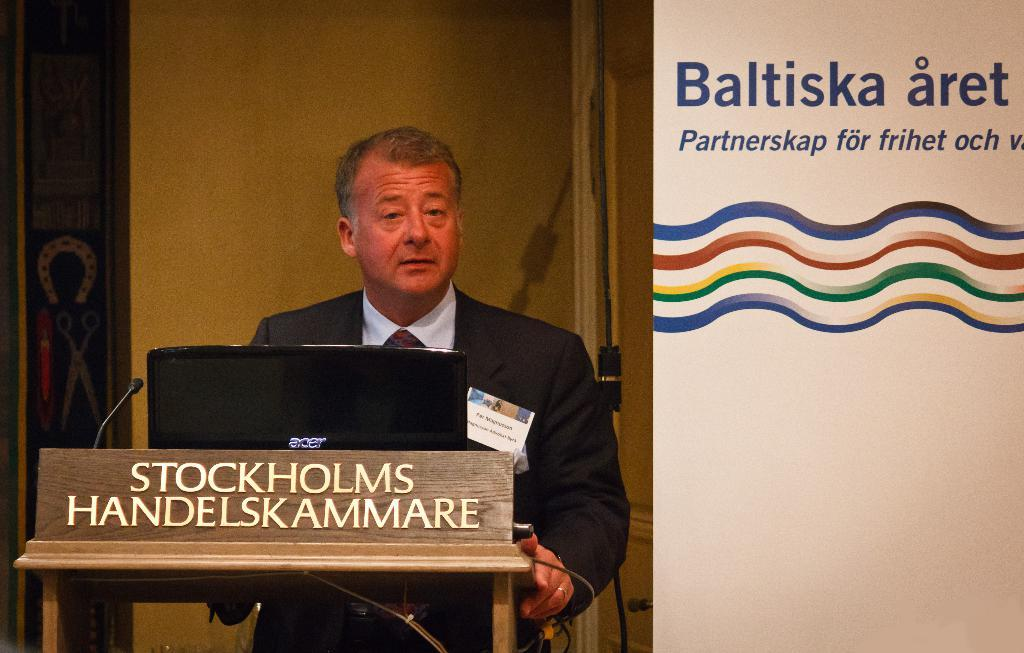What is the person in the image wearing? The person is wearing a suit. What objects are in front of the person? There is a laptop and a microphone in front of the person. What can be seen at the right back of the person? There is a white banner at the right back of the person. What type of shirt is visible in the fog in the image? There is no shirt or fog present in the image. How many eggs are on the white banner in the image? There are no eggs on the white banner in the image. 